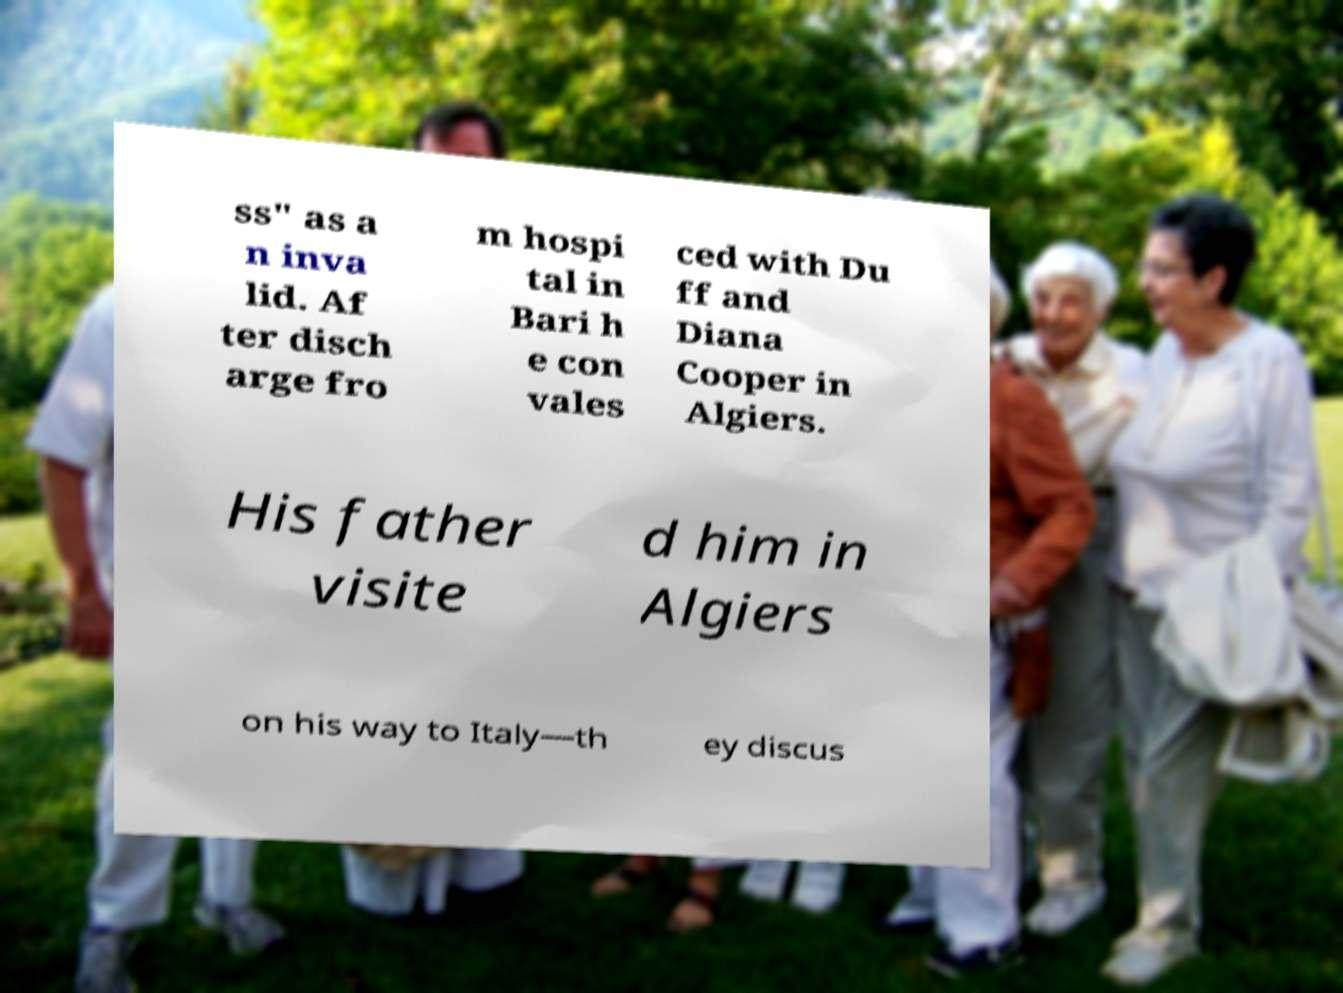What messages or text are displayed in this image? I need them in a readable, typed format. ss" as a n inva lid. Af ter disch arge fro m hospi tal in Bari h e con vales ced with Du ff and Diana Cooper in Algiers. His father visite d him in Algiers on his way to Italy—th ey discus 